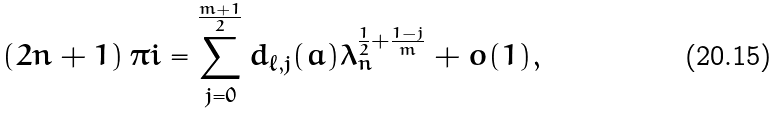Convert formula to latex. <formula><loc_0><loc_0><loc_500><loc_500>\left ( 2 n + 1 \right ) \pi i = \sum _ { j = 0 } ^ { \frac { m + 1 } { 2 } } d _ { \ell , j } ( a ) \lambda _ { n } ^ { \frac { 1 } { 2 } + \frac { 1 - j } { m } } + o ( 1 ) ,</formula> 